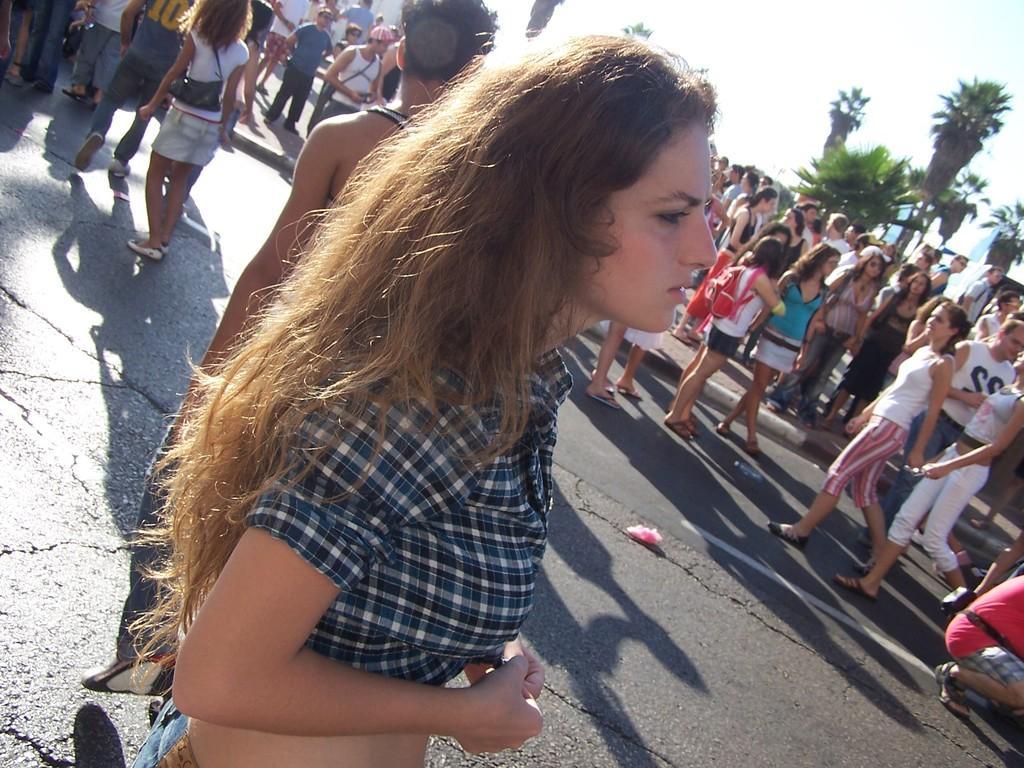How would you summarize this image in a sentence or two? In this picture we can see a group of people on the road, bags, trees and some objects and in the background we can see the sky. 